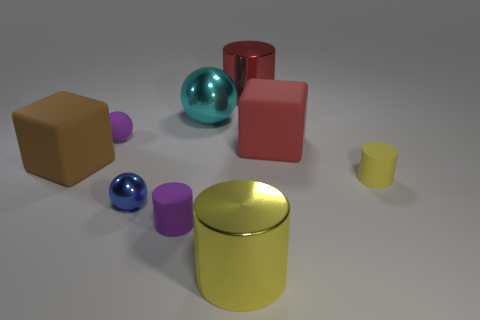Can you describe the shapes and colors of the objects in the image? Certainly! The image features a variety of geometric objects consisting of two spheres, one cyan and one blue; a large yellow cylinder; a small yellow cup; a big cyan cube; a small pink cylinder; a red cube; and two brown cubes, one smaller than the other. 